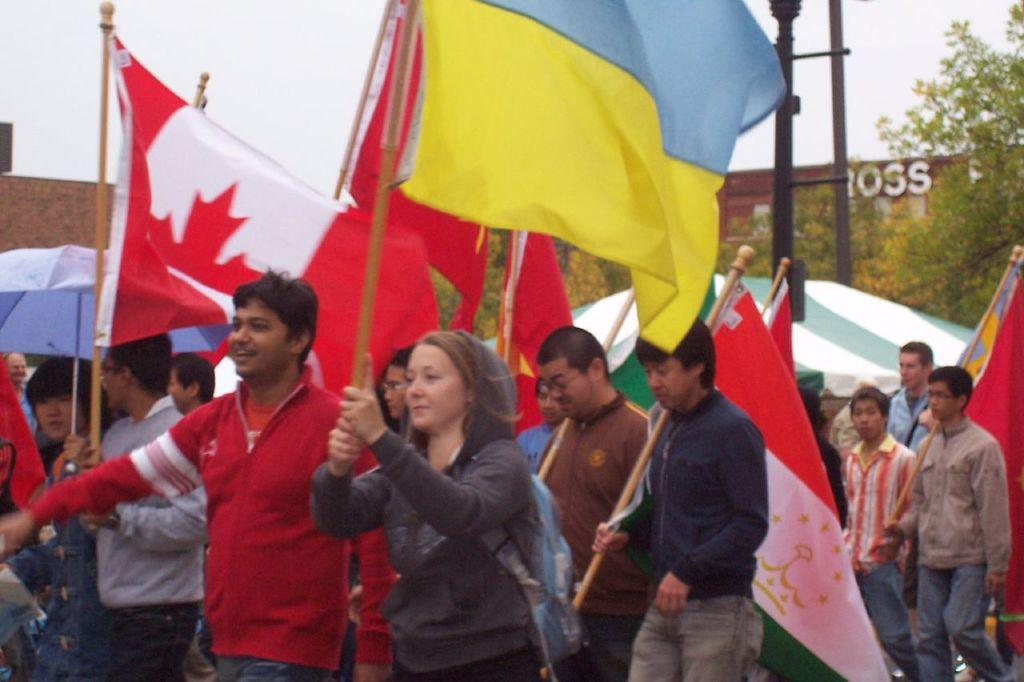Who or what is present in the image? There are people in the image. What are the people holding in the image? A: The people are holding flags in the image. What can be seen in the background of the image? There are trees and a house in the background of the image. What is visible at the top of the image? The sky is visible at the top of the image. How many toes are visible on the people in the image? There is no information about the people's toes in the image, so we cannot determine how many are visible. 